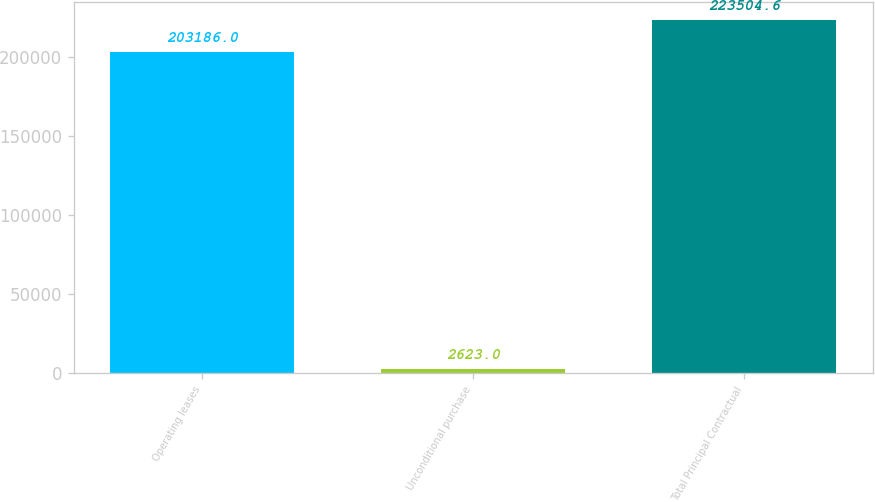Convert chart. <chart><loc_0><loc_0><loc_500><loc_500><bar_chart><fcel>Operating leases<fcel>Unconditional purchase<fcel>Total Principal Contractual<nl><fcel>203186<fcel>2623<fcel>223505<nl></chart> 